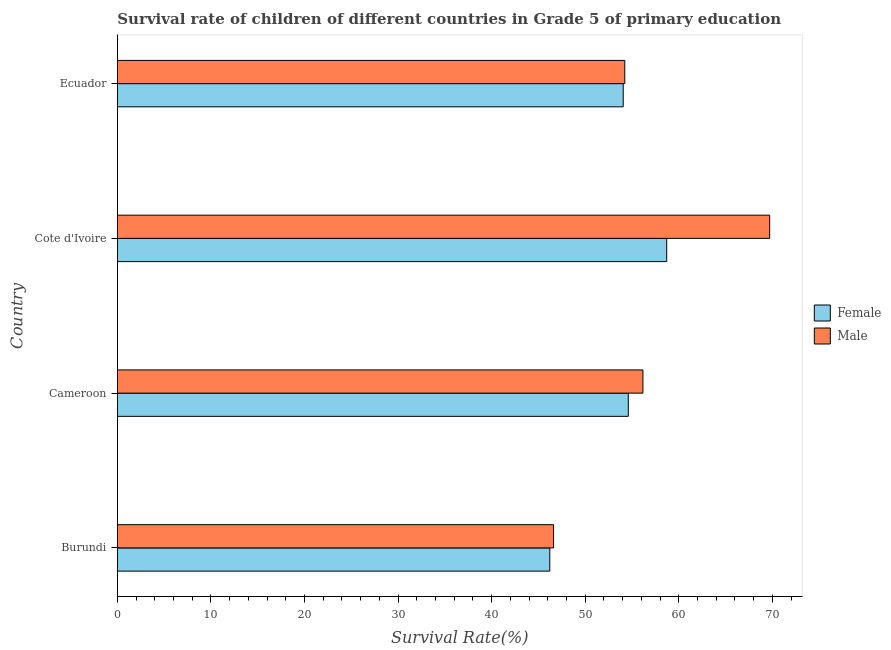How many different coloured bars are there?
Give a very brief answer. 2. Are the number of bars per tick equal to the number of legend labels?
Provide a short and direct response. Yes. How many bars are there on the 1st tick from the top?
Your answer should be very brief. 2. How many bars are there on the 1st tick from the bottom?
Give a very brief answer. 2. What is the label of the 3rd group of bars from the top?
Provide a short and direct response. Cameroon. What is the survival rate of male students in primary education in Burundi?
Provide a short and direct response. 46.61. Across all countries, what is the maximum survival rate of female students in primary education?
Ensure brevity in your answer.  58.71. Across all countries, what is the minimum survival rate of male students in primary education?
Keep it short and to the point. 46.61. In which country was the survival rate of female students in primary education maximum?
Your response must be concise. Cote d'Ivoire. In which country was the survival rate of female students in primary education minimum?
Provide a succinct answer. Burundi. What is the total survival rate of female students in primary education in the graph?
Provide a succinct answer. 213.58. What is the difference between the survival rate of female students in primary education in Cameroon and that in Cote d'Ivoire?
Provide a succinct answer. -4.11. What is the difference between the survival rate of male students in primary education in Ecuador and the survival rate of female students in primary education in Burundi?
Make the answer very short. 8.01. What is the average survival rate of female students in primary education per country?
Give a very brief answer. 53.4. What is the difference between the survival rate of female students in primary education and survival rate of male students in primary education in Burundi?
Provide a short and direct response. -0.4. In how many countries, is the survival rate of male students in primary education greater than 8 %?
Provide a short and direct response. 4. What is the ratio of the survival rate of male students in primary education in Burundi to that in Cameroon?
Your answer should be very brief. 0.83. Is the survival rate of male students in primary education in Burundi less than that in Cote d'Ivoire?
Your response must be concise. Yes. What is the difference between the highest and the second highest survival rate of male students in primary education?
Provide a succinct answer. 13.55. What is the difference between the highest and the lowest survival rate of male students in primary education?
Your response must be concise. 23.1. Is the sum of the survival rate of female students in primary education in Burundi and Ecuador greater than the maximum survival rate of male students in primary education across all countries?
Your answer should be compact. Yes. Are all the bars in the graph horizontal?
Ensure brevity in your answer.  Yes. How many countries are there in the graph?
Offer a very short reply. 4. How many legend labels are there?
Keep it short and to the point. 2. What is the title of the graph?
Provide a succinct answer. Survival rate of children of different countries in Grade 5 of primary education. What is the label or title of the X-axis?
Keep it short and to the point. Survival Rate(%). What is the Survival Rate(%) of Female in Burundi?
Your response must be concise. 46.21. What is the Survival Rate(%) in Male in Burundi?
Offer a terse response. 46.61. What is the Survival Rate(%) in Female in Cameroon?
Keep it short and to the point. 54.6. What is the Survival Rate(%) of Male in Cameroon?
Keep it short and to the point. 56.17. What is the Survival Rate(%) of Female in Cote d'Ivoire?
Provide a short and direct response. 58.71. What is the Survival Rate(%) of Male in Cote d'Ivoire?
Keep it short and to the point. 69.71. What is the Survival Rate(%) of Female in Ecuador?
Keep it short and to the point. 54.06. What is the Survival Rate(%) in Male in Ecuador?
Make the answer very short. 54.23. Across all countries, what is the maximum Survival Rate(%) in Female?
Your answer should be very brief. 58.71. Across all countries, what is the maximum Survival Rate(%) in Male?
Provide a succinct answer. 69.71. Across all countries, what is the minimum Survival Rate(%) in Female?
Your answer should be very brief. 46.21. Across all countries, what is the minimum Survival Rate(%) in Male?
Give a very brief answer. 46.61. What is the total Survival Rate(%) of Female in the graph?
Offer a very short reply. 213.58. What is the total Survival Rate(%) in Male in the graph?
Keep it short and to the point. 226.72. What is the difference between the Survival Rate(%) in Female in Burundi and that in Cameroon?
Offer a terse response. -8.39. What is the difference between the Survival Rate(%) of Male in Burundi and that in Cameroon?
Offer a terse response. -9.55. What is the difference between the Survival Rate(%) in Female in Burundi and that in Cote d'Ivoire?
Give a very brief answer. -12.49. What is the difference between the Survival Rate(%) of Male in Burundi and that in Cote d'Ivoire?
Offer a very short reply. -23.1. What is the difference between the Survival Rate(%) in Female in Burundi and that in Ecuador?
Make the answer very short. -7.85. What is the difference between the Survival Rate(%) in Male in Burundi and that in Ecuador?
Give a very brief answer. -7.61. What is the difference between the Survival Rate(%) in Female in Cameroon and that in Cote d'Ivoire?
Your answer should be very brief. -4.11. What is the difference between the Survival Rate(%) in Male in Cameroon and that in Cote d'Ivoire?
Your answer should be very brief. -13.55. What is the difference between the Survival Rate(%) of Female in Cameroon and that in Ecuador?
Ensure brevity in your answer.  0.54. What is the difference between the Survival Rate(%) in Male in Cameroon and that in Ecuador?
Provide a short and direct response. 1.94. What is the difference between the Survival Rate(%) in Female in Cote d'Ivoire and that in Ecuador?
Offer a very short reply. 4.65. What is the difference between the Survival Rate(%) of Male in Cote d'Ivoire and that in Ecuador?
Your answer should be very brief. 15.49. What is the difference between the Survival Rate(%) of Female in Burundi and the Survival Rate(%) of Male in Cameroon?
Offer a very short reply. -9.95. What is the difference between the Survival Rate(%) of Female in Burundi and the Survival Rate(%) of Male in Cote d'Ivoire?
Offer a terse response. -23.5. What is the difference between the Survival Rate(%) in Female in Burundi and the Survival Rate(%) in Male in Ecuador?
Make the answer very short. -8.01. What is the difference between the Survival Rate(%) in Female in Cameroon and the Survival Rate(%) in Male in Cote d'Ivoire?
Provide a succinct answer. -15.11. What is the difference between the Survival Rate(%) in Female in Cameroon and the Survival Rate(%) in Male in Ecuador?
Your response must be concise. 0.38. What is the difference between the Survival Rate(%) of Female in Cote d'Ivoire and the Survival Rate(%) of Male in Ecuador?
Provide a succinct answer. 4.48. What is the average Survival Rate(%) in Female per country?
Offer a terse response. 53.4. What is the average Survival Rate(%) in Male per country?
Offer a terse response. 56.68. What is the difference between the Survival Rate(%) in Female and Survival Rate(%) in Male in Burundi?
Keep it short and to the point. -0.4. What is the difference between the Survival Rate(%) of Female and Survival Rate(%) of Male in Cameroon?
Keep it short and to the point. -1.56. What is the difference between the Survival Rate(%) in Female and Survival Rate(%) in Male in Cote d'Ivoire?
Offer a very short reply. -11.01. What is the difference between the Survival Rate(%) in Female and Survival Rate(%) in Male in Ecuador?
Offer a terse response. -0.17. What is the ratio of the Survival Rate(%) in Female in Burundi to that in Cameroon?
Provide a succinct answer. 0.85. What is the ratio of the Survival Rate(%) of Male in Burundi to that in Cameroon?
Ensure brevity in your answer.  0.83. What is the ratio of the Survival Rate(%) in Female in Burundi to that in Cote d'Ivoire?
Your response must be concise. 0.79. What is the ratio of the Survival Rate(%) of Male in Burundi to that in Cote d'Ivoire?
Your answer should be very brief. 0.67. What is the ratio of the Survival Rate(%) of Female in Burundi to that in Ecuador?
Provide a short and direct response. 0.85. What is the ratio of the Survival Rate(%) of Male in Burundi to that in Ecuador?
Your response must be concise. 0.86. What is the ratio of the Survival Rate(%) in Female in Cameroon to that in Cote d'Ivoire?
Your answer should be very brief. 0.93. What is the ratio of the Survival Rate(%) of Male in Cameroon to that in Cote d'Ivoire?
Offer a terse response. 0.81. What is the ratio of the Survival Rate(%) of Female in Cameroon to that in Ecuador?
Your answer should be very brief. 1.01. What is the ratio of the Survival Rate(%) of Male in Cameroon to that in Ecuador?
Provide a short and direct response. 1.04. What is the ratio of the Survival Rate(%) of Female in Cote d'Ivoire to that in Ecuador?
Offer a very short reply. 1.09. What is the ratio of the Survival Rate(%) of Male in Cote d'Ivoire to that in Ecuador?
Make the answer very short. 1.29. What is the difference between the highest and the second highest Survival Rate(%) in Female?
Provide a short and direct response. 4.11. What is the difference between the highest and the second highest Survival Rate(%) in Male?
Ensure brevity in your answer.  13.55. What is the difference between the highest and the lowest Survival Rate(%) in Female?
Your answer should be compact. 12.49. What is the difference between the highest and the lowest Survival Rate(%) of Male?
Ensure brevity in your answer.  23.1. 